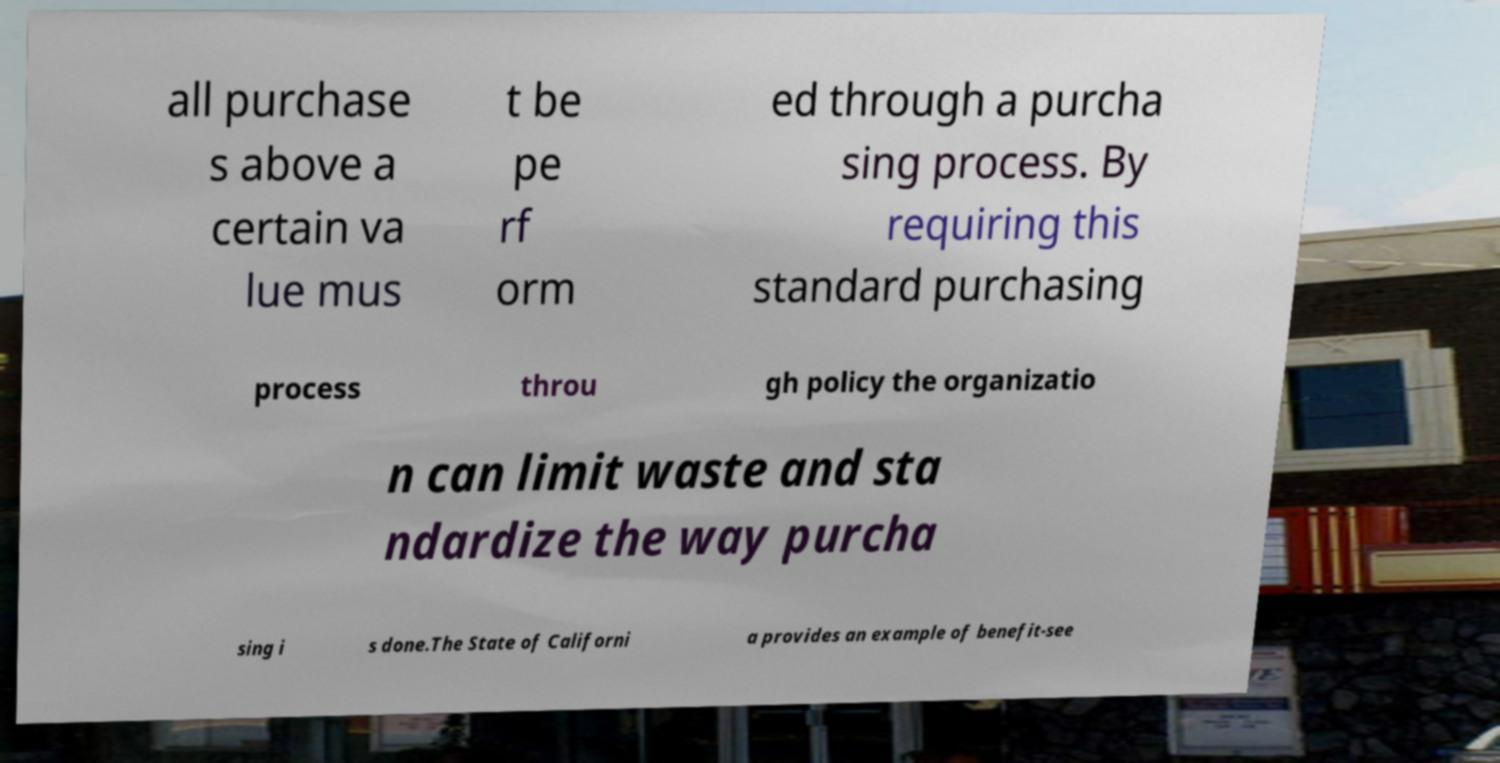Please identify and transcribe the text found in this image. all purchase s above a certain va lue mus t be pe rf orm ed through a purcha sing process. By requiring this standard purchasing process throu gh policy the organizatio n can limit waste and sta ndardize the way purcha sing i s done.The State of Californi a provides an example of benefit-see 